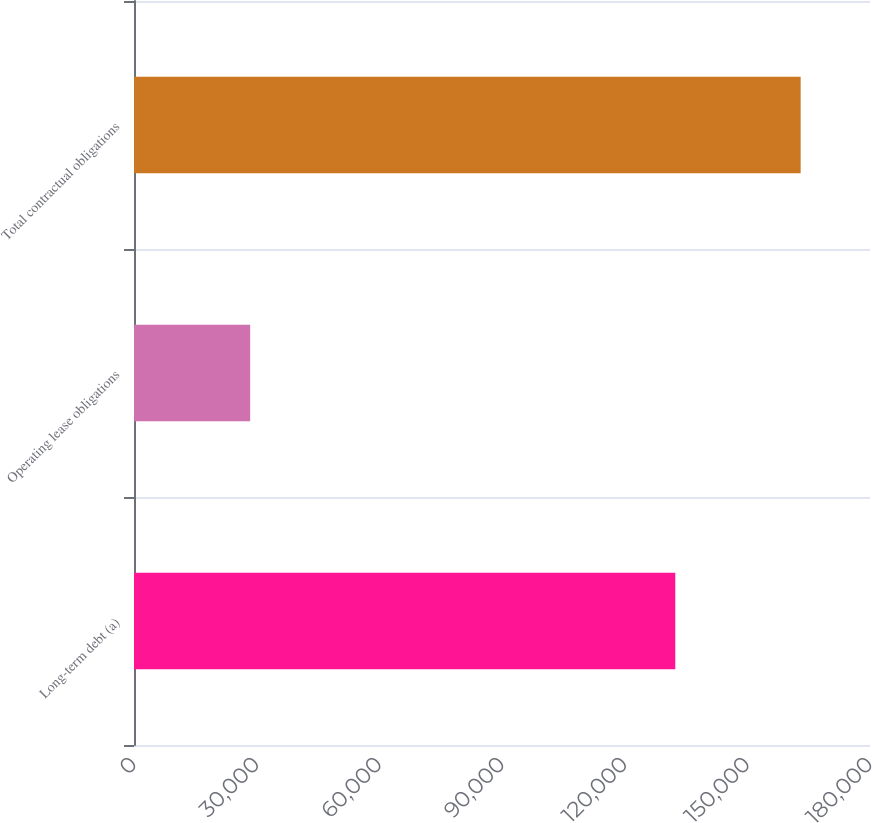Convert chart to OTSL. <chart><loc_0><loc_0><loc_500><loc_500><bar_chart><fcel>Long-term debt (a)<fcel>Operating lease obligations<fcel>Total contractual obligations<nl><fcel>132378<fcel>28407<fcel>163045<nl></chart> 